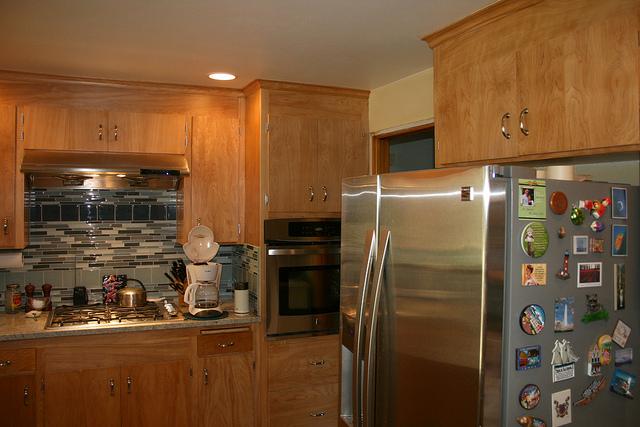What room is this?
Quick response, please. Kitchen. What color are the lights above the counter?
Concise answer only. White. How many magnets are on the refrigerator?
Be succinct. 29. What color is the backsplash?
Answer briefly. Gray. 